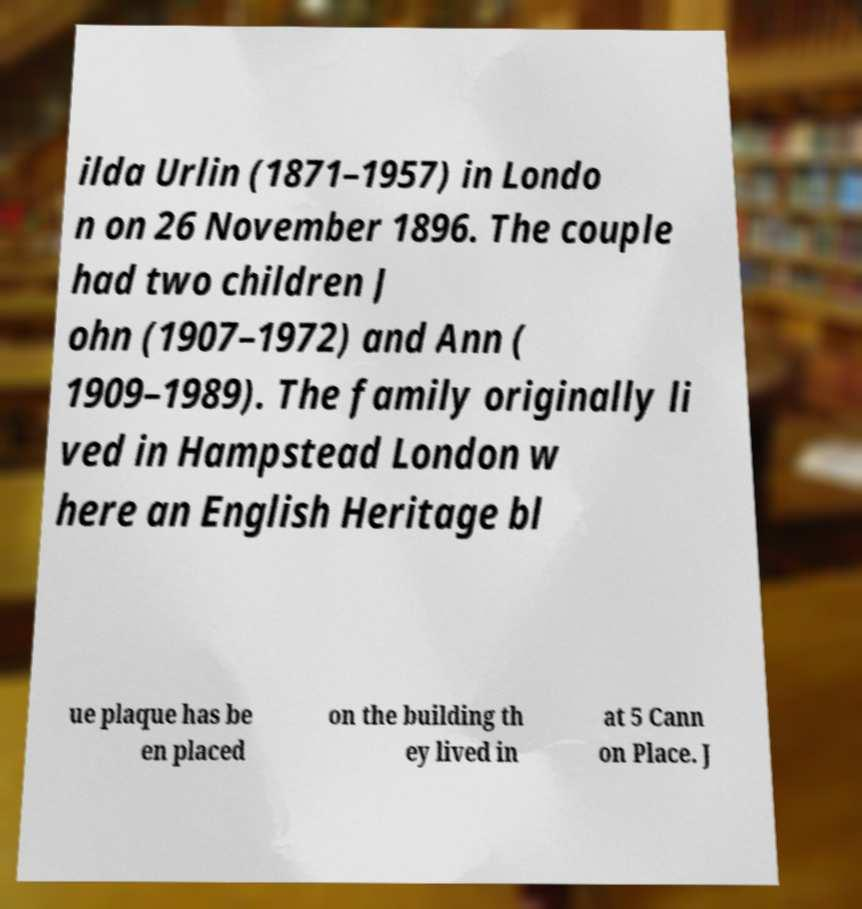I need the written content from this picture converted into text. Can you do that? ilda Urlin (1871–1957) in Londo n on 26 November 1896. The couple had two children J ohn (1907–1972) and Ann ( 1909–1989). The family originally li ved in Hampstead London w here an English Heritage bl ue plaque has be en placed on the building th ey lived in at 5 Cann on Place. J 